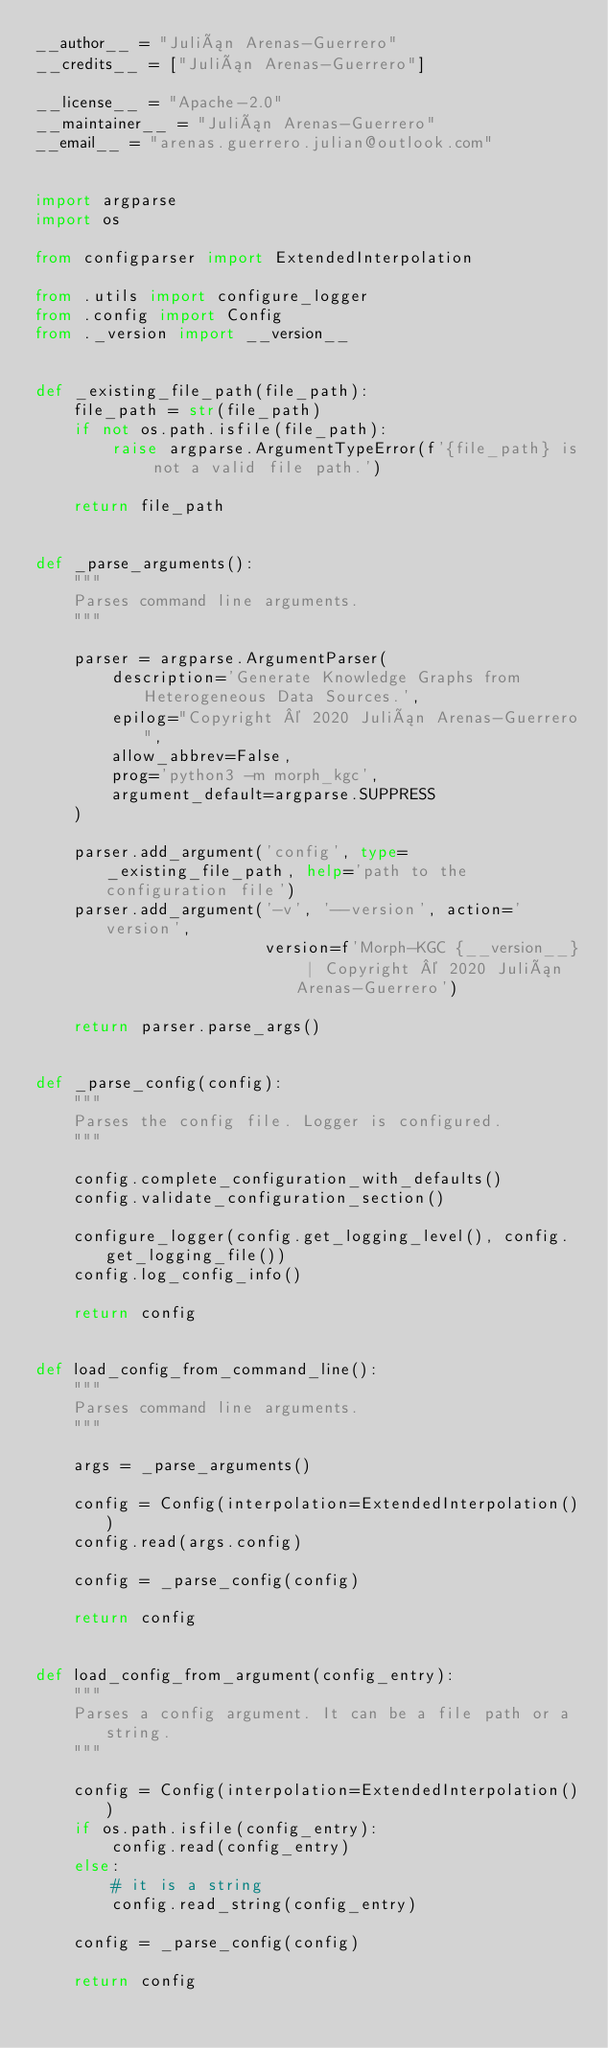<code> <loc_0><loc_0><loc_500><loc_500><_Python_>__author__ = "Julián Arenas-Guerrero"
__credits__ = ["Julián Arenas-Guerrero"]

__license__ = "Apache-2.0"
__maintainer__ = "Julián Arenas-Guerrero"
__email__ = "arenas.guerrero.julian@outlook.com"


import argparse
import os

from configparser import ExtendedInterpolation

from .utils import configure_logger
from .config import Config
from ._version import __version__


def _existing_file_path(file_path):
    file_path = str(file_path)
    if not os.path.isfile(file_path):
        raise argparse.ArgumentTypeError(f'{file_path} is not a valid file path.')

    return file_path


def _parse_arguments():
    """
    Parses command line arguments.
    """

    parser = argparse.ArgumentParser(
        description='Generate Knowledge Graphs from Heterogeneous Data Sources.',
        epilog="Copyright © 2020 Julián Arenas-Guerrero",
        allow_abbrev=False,
        prog='python3 -m morph_kgc',
        argument_default=argparse.SUPPRESS
    )

    parser.add_argument('config', type=_existing_file_path, help='path to the configuration file')
    parser.add_argument('-v', '--version', action='version',
                        version=f'Morph-KGC {__version__} | Copyright © 2020 Julián Arenas-Guerrero')

    return parser.parse_args()


def _parse_config(config):
    """
    Parses the config file. Logger is configured.
    """

    config.complete_configuration_with_defaults()
    config.validate_configuration_section()

    configure_logger(config.get_logging_level(), config.get_logging_file())
    config.log_config_info()

    return config


def load_config_from_command_line():
    """
    Parses command line arguments.
    """

    args = _parse_arguments()

    config = Config(interpolation=ExtendedInterpolation())
    config.read(args.config)

    config = _parse_config(config)

    return config


def load_config_from_argument(config_entry):
    """
    Parses a config argument. It can be a file path or a string.
    """

    config = Config(interpolation=ExtendedInterpolation())
    if os.path.isfile(config_entry):
        config.read(config_entry)
    else:
        # it is a string
        config.read_string(config_entry)

    config = _parse_config(config)

    return config
</code> 